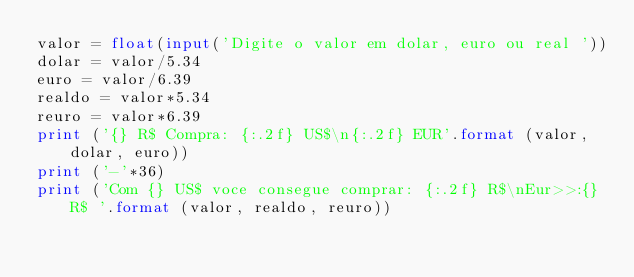<code> <loc_0><loc_0><loc_500><loc_500><_Python_>valor = float(input('Digite o valor em dolar, euro ou real '))
dolar = valor/5.34
euro = valor/6.39
realdo = valor*5.34
reuro = valor*6.39
print ('{} R$ Compra: {:.2f} US$\n{:.2f} EUR'.format (valor, dolar, euro))
print ('-'*36)
print ('Com {} US$ voce consegue comprar: {:.2f} R$\nEur>>:{} R$ '.format (valor, realdo, reuro))
</code> 